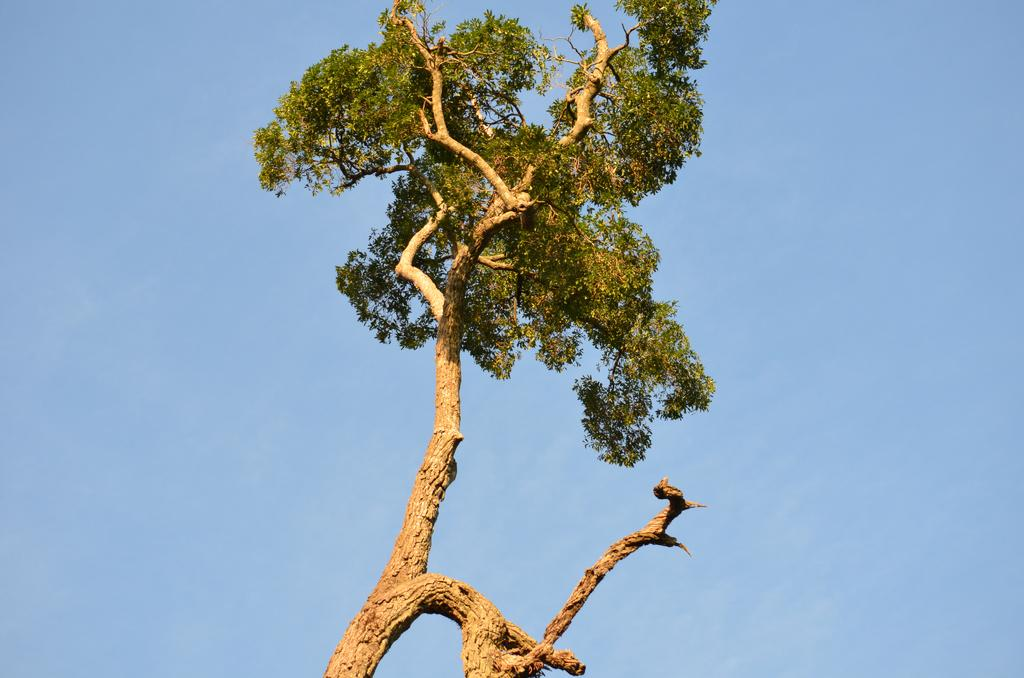What is the weather like in the image? It is a sunny day in the image. What can be seen in the middle of the image? There is a tree in the middle of the image. What is visible in the background of the image? The sky is visible in the background of the image. Where might the image have been taken? The image might have been taken from outside the city. Reasoning: Let' Let's think step by step in order to produce the conversation. We start by identifying the weather condition in the image, which is sunny. Then, we focus on the main subject in the image, which is the tree. Next, we describe the background of the image, which includes the sky. Finally, we speculate on the location of the image, suggesting that it might have been taken from outside the city. Absurd Question/Answer: How many chairs are visible in the image? There are no chairs present in the image. What type of hospital can be seen in the background of the image? There is no hospital visible in the image; it features a tree and a sky background. 